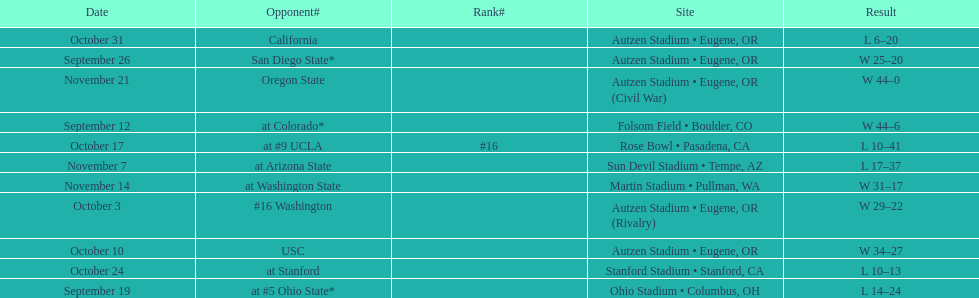How many wins are listed for the season? 6. 